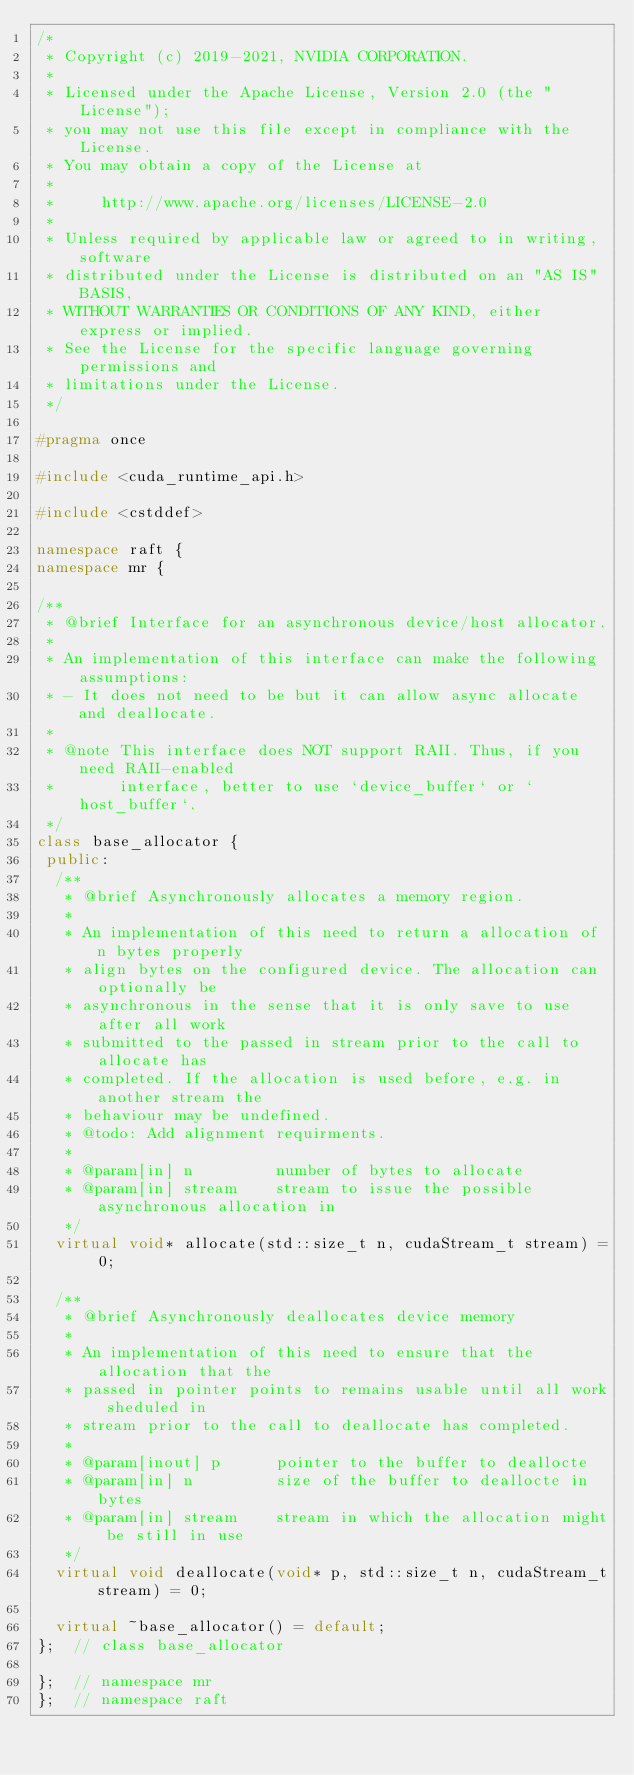Convert code to text. <code><loc_0><loc_0><loc_500><loc_500><_C++_>/*
 * Copyright (c) 2019-2021, NVIDIA CORPORATION.
 *
 * Licensed under the Apache License, Version 2.0 (the "License");
 * you may not use this file except in compliance with the License.
 * You may obtain a copy of the License at
 *
 *     http://www.apache.org/licenses/LICENSE-2.0
 *
 * Unless required by applicable law or agreed to in writing, software
 * distributed under the License is distributed on an "AS IS" BASIS,
 * WITHOUT WARRANTIES OR CONDITIONS OF ANY KIND, either express or implied.
 * See the License for the specific language governing permissions and
 * limitations under the License.
 */

#pragma once

#include <cuda_runtime_api.h>

#include <cstddef>

namespace raft {
namespace mr {

/**
 * @brief Interface for an asynchronous device/host allocator.
 *
 * An implementation of this interface can make the following assumptions:
 * - It does not need to be but it can allow async allocate and deallocate.
 *
 * @note This interface does NOT support RAII. Thus, if you need RAII-enabled
 *       interface, better to use `device_buffer` or `host_buffer`.
 */
class base_allocator {
 public:
  /**
   * @brief Asynchronously allocates a memory region.
   *
   * An implementation of this need to return a allocation of n bytes properly
   * align bytes on the configured device. The allocation can optionally be
   * asynchronous in the sense that it is only save to use after all work
   * submitted to the passed in stream prior to the call to allocate has
   * completed. If the allocation is used before, e.g. in another stream the
   * behaviour may be undefined.
   * @todo: Add alignment requirments.
   *
   * @param[in] n         number of bytes to allocate
   * @param[in] stream    stream to issue the possible asynchronous allocation in
   */
  virtual void* allocate(std::size_t n, cudaStream_t stream) = 0;

  /**
   * @brief Asynchronously deallocates device memory
   *
   * An implementation of this need to ensure that the allocation that the
   * passed in pointer points to remains usable until all work sheduled in
   * stream prior to the call to deallocate has completed.
   *
   * @param[inout] p      pointer to the buffer to deallocte
   * @param[in] n         size of the buffer to deallocte in bytes
   * @param[in] stream    stream in which the allocation might be still in use
   */
  virtual void deallocate(void* p, std::size_t n, cudaStream_t stream) = 0;

  virtual ~base_allocator() = default;
};  // class base_allocator

};  // namespace mr
};  // namespace raft
</code> 